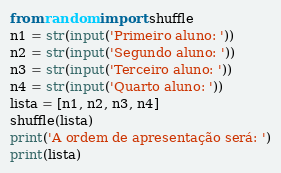<code> <loc_0><loc_0><loc_500><loc_500><_Python_>from random import shuffle
n1 = str(input('Primeiro aluno: '))
n2 = str(input('Segundo aluno: '))
n3 = str(input('Terceiro aluno: '))
n4 = str(input('Quarto aluno: '))
lista = [n1, n2, n3, n4]
shuffle(lista)
print('A ordem de apresentação será: ')
print(lista)
</code> 